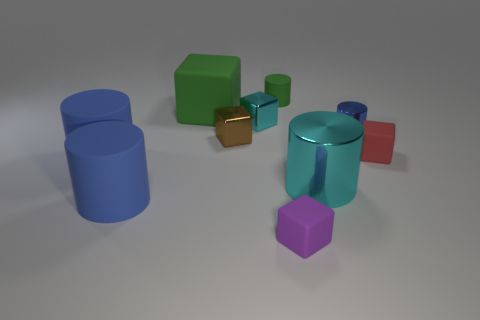How many blue cylinders must be subtracted to get 1 blue cylinders? 2 Subtract all blue blocks. How many blue cylinders are left? 3 Subtract all big matte cylinders. How many cylinders are left? 3 Subtract all purple blocks. How many blocks are left? 4 Subtract 2 blocks. How many blocks are left? 3 Subtract all yellow cylinders. Subtract all cyan spheres. How many cylinders are left? 5 Subtract 1 cyan blocks. How many objects are left? 9 Subtract all large red things. Subtract all small green cylinders. How many objects are left? 9 Add 8 tiny red matte things. How many tiny red matte things are left? 9 Add 7 small green matte cylinders. How many small green matte cylinders exist? 8 